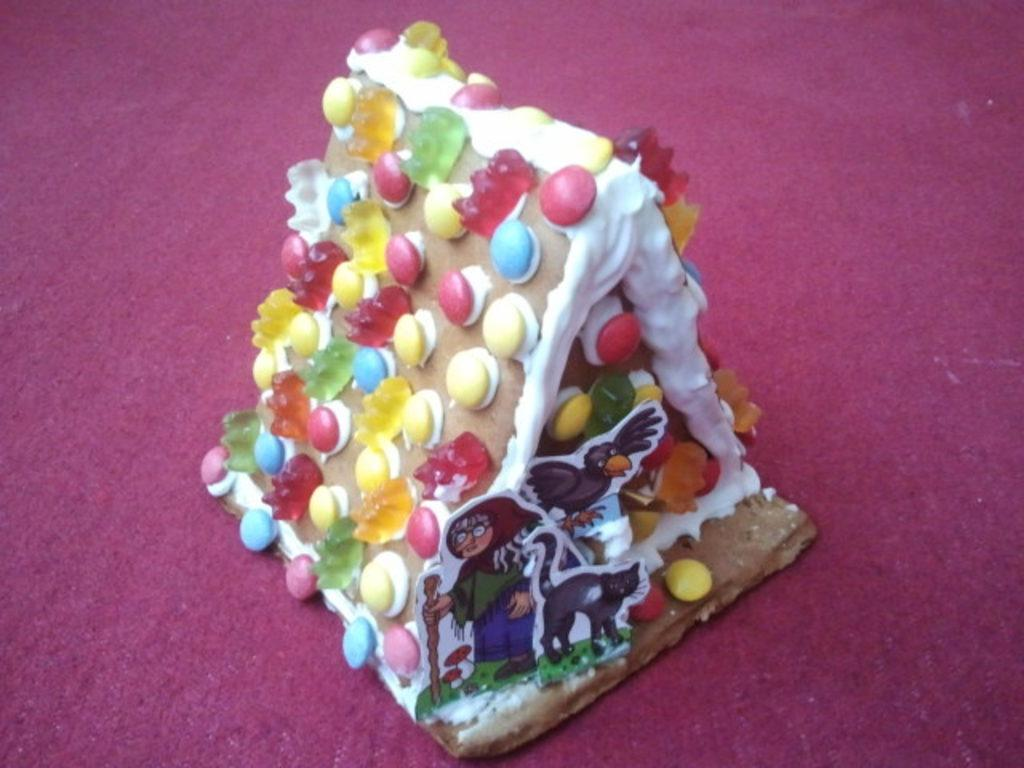What is the main subject of the image? There is a cake in the image. Where is the cake located? The cake is placed on a surface. What type of scarecrow is reading a book next to the cake in the image? There is no scarecrow or book present in the image; it only features a cake placed on a surface. 